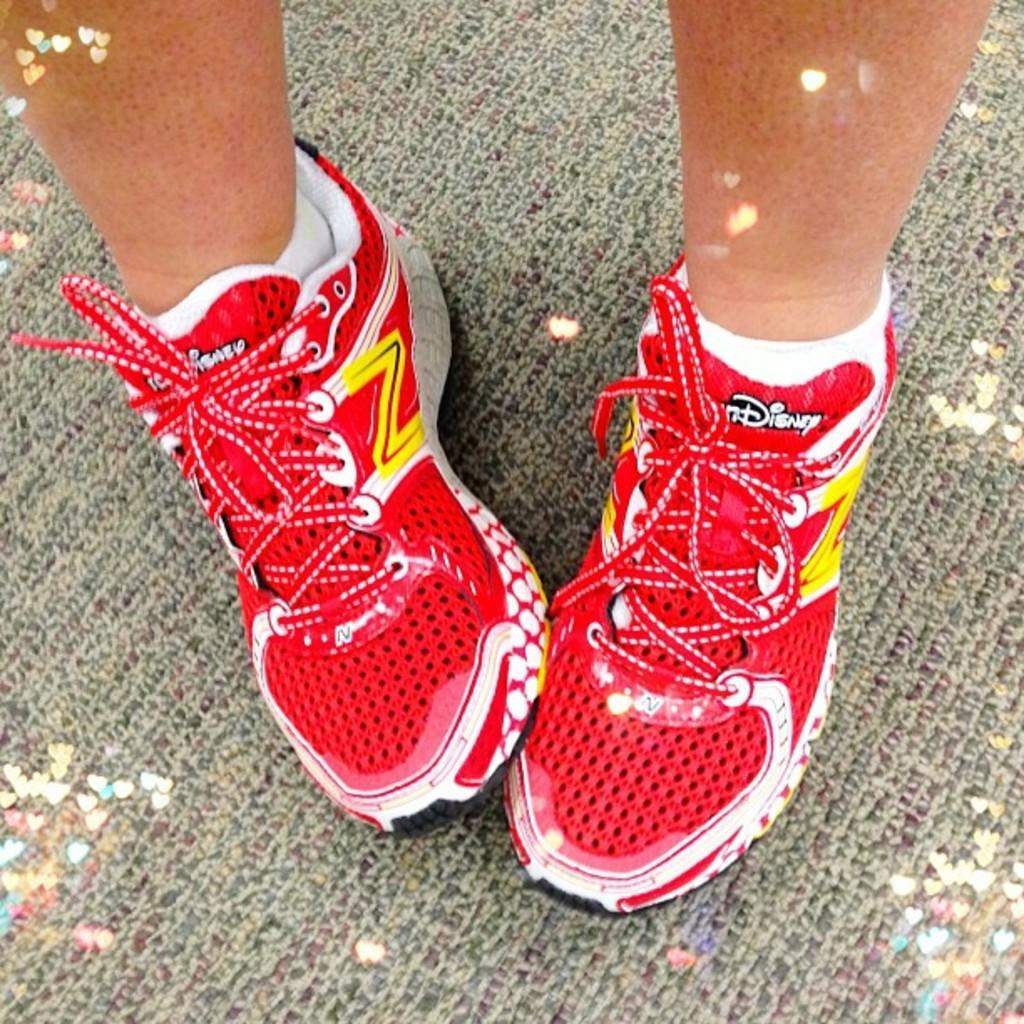What is the main subject of the image? There is a person in the image. Can you describe the shoes the person is wearing? The person is wearing shoes with red, white, and yellow color combinations. What is the position of the person's feet in the image? The person has both feet placed on a surface. What type of basketball is the person holding in the image? There is no basketball present in the image. Can you tell me the relationship between the person and their father in the image? There is no information about the person's father in the image. 